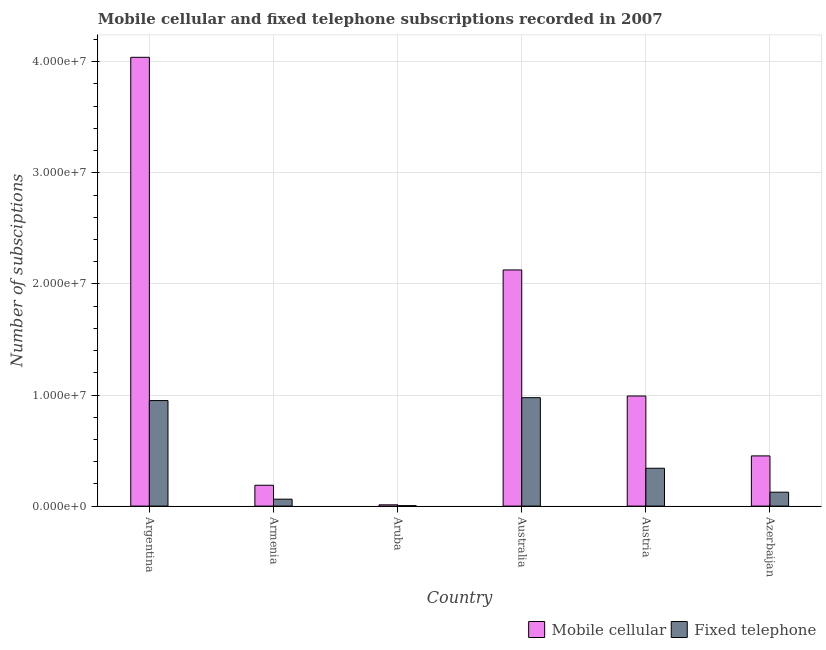How many groups of bars are there?
Your response must be concise. 6. Are the number of bars per tick equal to the number of legend labels?
Your answer should be very brief. Yes. How many bars are there on the 4th tick from the left?
Offer a terse response. 2. How many bars are there on the 1st tick from the right?
Offer a very short reply. 2. What is the label of the 1st group of bars from the left?
Your response must be concise. Argentina. What is the number of mobile cellular subscriptions in Argentina?
Your answer should be compact. 4.04e+07. Across all countries, what is the maximum number of mobile cellular subscriptions?
Your response must be concise. 4.04e+07. Across all countries, what is the minimum number of fixed telephone subscriptions?
Provide a short and direct response. 3.86e+04. In which country was the number of mobile cellular subscriptions minimum?
Provide a succinct answer. Aruba. What is the total number of fixed telephone subscriptions in the graph?
Offer a terse response. 2.46e+07. What is the difference between the number of mobile cellular subscriptions in Armenia and that in Azerbaijan?
Offer a very short reply. -2.64e+06. What is the difference between the number of mobile cellular subscriptions in Azerbaijan and the number of fixed telephone subscriptions in Austria?
Your answer should be compact. 1.11e+06. What is the average number of mobile cellular subscriptions per country?
Give a very brief answer. 1.30e+07. What is the difference between the number of mobile cellular subscriptions and number of fixed telephone subscriptions in Australia?
Make the answer very short. 1.15e+07. In how many countries, is the number of mobile cellular subscriptions greater than 14000000 ?
Your answer should be compact. 2. What is the ratio of the number of fixed telephone subscriptions in Argentina to that in Azerbaijan?
Your answer should be very brief. 7.58. Is the number of fixed telephone subscriptions in Armenia less than that in Aruba?
Provide a short and direct response. No. What is the difference between the highest and the second highest number of mobile cellular subscriptions?
Your answer should be compact. 1.91e+07. What is the difference between the highest and the lowest number of fixed telephone subscriptions?
Provide a short and direct response. 9.72e+06. What does the 1st bar from the left in Aruba represents?
Offer a terse response. Mobile cellular. What does the 2nd bar from the right in Australia represents?
Your response must be concise. Mobile cellular. Are all the bars in the graph horizontal?
Your answer should be very brief. No. How many countries are there in the graph?
Provide a succinct answer. 6. Are the values on the major ticks of Y-axis written in scientific E-notation?
Provide a succinct answer. Yes. Does the graph contain any zero values?
Provide a short and direct response. No. How many legend labels are there?
Your answer should be compact. 2. What is the title of the graph?
Make the answer very short. Mobile cellular and fixed telephone subscriptions recorded in 2007. Does "Highest 10% of population" appear as one of the legend labels in the graph?
Provide a succinct answer. No. What is the label or title of the X-axis?
Your answer should be very brief. Country. What is the label or title of the Y-axis?
Offer a terse response. Number of subsciptions. What is the Number of subsciptions of Mobile cellular in Argentina?
Offer a very short reply. 4.04e+07. What is the Number of subsciptions of Fixed telephone in Argentina?
Ensure brevity in your answer.  9.50e+06. What is the Number of subsciptions in Mobile cellular in Armenia?
Offer a terse response. 1.88e+06. What is the Number of subsciptions of Fixed telephone in Armenia?
Provide a succinct answer. 6.25e+05. What is the Number of subsciptions of Mobile cellular in Aruba?
Provide a short and direct response. 1.14e+05. What is the Number of subsciptions of Fixed telephone in Aruba?
Offer a terse response. 3.86e+04. What is the Number of subsciptions in Mobile cellular in Australia?
Give a very brief answer. 2.13e+07. What is the Number of subsciptions of Fixed telephone in Australia?
Offer a terse response. 9.76e+06. What is the Number of subsciptions in Mobile cellular in Austria?
Keep it short and to the point. 9.91e+06. What is the Number of subsciptions in Fixed telephone in Austria?
Offer a very short reply. 3.41e+06. What is the Number of subsciptions in Mobile cellular in Azerbaijan?
Keep it short and to the point. 4.52e+06. What is the Number of subsciptions of Fixed telephone in Azerbaijan?
Offer a terse response. 1.25e+06. Across all countries, what is the maximum Number of subsciptions of Mobile cellular?
Offer a very short reply. 4.04e+07. Across all countries, what is the maximum Number of subsciptions in Fixed telephone?
Provide a short and direct response. 9.76e+06. Across all countries, what is the minimum Number of subsciptions in Mobile cellular?
Offer a very short reply. 1.14e+05. Across all countries, what is the minimum Number of subsciptions in Fixed telephone?
Give a very brief answer. 3.86e+04. What is the total Number of subsciptions of Mobile cellular in the graph?
Provide a short and direct response. 7.81e+07. What is the total Number of subsciptions of Fixed telephone in the graph?
Your answer should be compact. 2.46e+07. What is the difference between the Number of subsciptions in Mobile cellular in Argentina and that in Armenia?
Provide a succinct answer. 3.85e+07. What is the difference between the Number of subsciptions of Fixed telephone in Argentina and that in Armenia?
Give a very brief answer. 8.88e+06. What is the difference between the Number of subsciptions of Mobile cellular in Argentina and that in Aruba?
Ensure brevity in your answer.  4.03e+07. What is the difference between the Number of subsciptions of Fixed telephone in Argentina and that in Aruba?
Ensure brevity in your answer.  9.46e+06. What is the difference between the Number of subsciptions in Mobile cellular in Argentina and that in Australia?
Provide a short and direct response. 1.91e+07. What is the difference between the Number of subsciptions of Mobile cellular in Argentina and that in Austria?
Ensure brevity in your answer.  3.05e+07. What is the difference between the Number of subsciptions of Fixed telephone in Argentina and that in Austria?
Give a very brief answer. 6.09e+06. What is the difference between the Number of subsciptions of Mobile cellular in Argentina and that in Azerbaijan?
Your response must be concise. 3.59e+07. What is the difference between the Number of subsciptions in Fixed telephone in Argentina and that in Azerbaijan?
Your answer should be very brief. 8.25e+06. What is the difference between the Number of subsciptions in Mobile cellular in Armenia and that in Aruba?
Your response must be concise. 1.76e+06. What is the difference between the Number of subsciptions of Fixed telephone in Armenia and that in Aruba?
Give a very brief answer. 5.86e+05. What is the difference between the Number of subsciptions of Mobile cellular in Armenia and that in Australia?
Give a very brief answer. -1.94e+07. What is the difference between the Number of subsciptions in Fixed telephone in Armenia and that in Australia?
Offer a terse response. -9.14e+06. What is the difference between the Number of subsciptions of Mobile cellular in Armenia and that in Austria?
Offer a very short reply. -8.04e+06. What is the difference between the Number of subsciptions of Fixed telephone in Armenia and that in Austria?
Give a very brief answer. -2.78e+06. What is the difference between the Number of subsciptions of Mobile cellular in Armenia and that in Azerbaijan?
Offer a terse response. -2.64e+06. What is the difference between the Number of subsciptions of Fixed telephone in Armenia and that in Azerbaijan?
Your answer should be very brief. -6.29e+05. What is the difference between the Number of subsciptions in Mobile cellular in Aruba and that in Australia?
Your response must be concise. -2.11e+07. What is the difference between the Number of subsciptions in Fixed telephone in Aruba and that in Australia?
Your answer should be very brief. -9.72e+06. What is the difference between the Number of subsciptions in Mobile cellular in Aruba and that in Austria?
Provide a succinct answer. -9.80e+06. What is the difference between the Number of subsciptions in Fixed telephone in Aruba and that in Austria?
Give a very brief answer. -3.37e+06. What is the difference between the Number of subsciptions in Mobile cellular in Aruba and that in Azerbaijan?
Provide a short and direct response. -4.41e+06. What is the difference between the Number of subsciptions in Fixed telephone in Aruba and that in Azerbaijan?
Offer a very short reply. -1.21e+06. What is the difference between the Number of subsciptions in Mobile cellular in Australia and that in Austria?
Your response must be concise. 1.13e+07. What is the difference between the Number of subsciptions in Fixed telephone in Australia and that in Austria?
Offer a terse response. 6.35e+06. What is the difference between the Number of subsciptions in Mobile cellular in Australia and that in Azerbaijan?
Give a very brief answer. 1.67e+07. What is the difference between the Number of subsciptions in Fixed telephone in Australia and that in Azerbaijan?
Your answer should be compact. 8.51e+06. What is the difference between the Number of subsciptions in Mobile cellular in Austria and that in Azerbaijan?
Offer a terse response. 5.39e+06. What is the difference between the Number of subsciptions of Fixed telephone in Austria and that in Azerbaijan?
Give a very brief answer. 2.15e+06. What is the difference between the Number of subsciptions in Mobile cellular in Argentina and the Number of subsciptions in Fixed telephone in Armenia?
Ensure brevity in your answer.  3.98e+07. What is the difference between the Number of subsciptions in Mobile cellular in Argentina and the Number of subsciptions in Fixed telephone in Aruba?
Provide a succinct answer. 4.04e+07. What is the difference between the Number of subsciptions in Mobile cellular in Argentina and the Number of subsciptions in Fixed telephone in Australia?
Give a very brief answer. 3.06e+07. What is the difference between the Number of subsciptions in Mobile cellular in Argentina and the Number of subsciptions in Fixed telephone in Austria?
Make the answer very short. 3.70e+07. What is the difference between the Number of subsciptions of Mobile cellular in Argentina and the Number of subsciptions of Fixed telephone in Azerbaijan?
Provide a short and direct response. 3.91e+07. What is the difference between the Number of subsciptions in Mobile cellular in Armenia and the Number of subsciptions in Fixed telephone in Aruba?
Ensure brevity in your answer.  1.84e+06. What is the difference between the Number of subsciptions in Mobile cellular in Armenia and the Number of subsciptions in Fixed telephone in Australia?
Your answer should be compact. -7.88e+06. What is the difference between the Number of subsciptions of Mobile cellular in Armenia and the Number of subsciptions of Fixed telephone in Austria?
Keep it short and to the point. -1.53e+06. What is the difference between the Number of subsciptions in Mobile cellular in Armenia and the Number of subsciptions in Fixed telephone in Azerbaijan?
Provide a succinct answer. 6.23e+05. What is the difference between the Number of subsciptions in Mobile cellular in Aruba and the Number of subsciptions in Fixed telephone in Australia?
Keep it short and to the point. -9.65e+06. What is the difference between the Number of subsciptions of Mobile cellular in Aruba and the Number of subsciptions of Fixed telephone in Austria?
Provide a succinct answer. -3.29e+06. What is the difference between the Number of subsciptions in Mobile cellular in Aruba and the Number of subsciptions in Fixed telephone in Azerbaijan?
Your answer should be compact. -1.14e+06. What is the difference between the Number of subsciptions in Mobile cellular in Australia and the Number of subsciptions in Fixed telephone in Austria?
Ensure brevity in your answer.  1.79e+07. What is the difference between the Number of subsciptions in Mobile cellular in Australia and the Number of subsciptions in Fixed telephone in Azerbaijan?
Your answer should be compact. 2.00e+07. What is the difference between the Number of subsciptions in Mobile cellular in Austria and the Number of subsciptions in Fixed telephone in Azerbaijan?
Your answer should be very brief. 8.66e+06. What is the average Number of subsciptions in Mobile cellular per country?
Make the answer very short. 1.30e+07. What is the average Number of subsciptions in Fixed telephone per country?
Give a very brief answer. 4.10e+06. What is the difference between the Number of subsciptions of Mobile cellular and Number of subsciptions of Fixed telephone in Argentina?
Offer a terse response. 3.09e+07. What is the difference between the Number of subsciptions in Mobile cellular and Number of subsciptions in Fixed telephone in Armenia?
Provide a succinct answer. 1.25e+06. What is the difference between the Number of subsciptions of Mobile cellular and Number of subsciptions of Fixed telephone in Aruba?
Make the answer very short. 7.50e+04. What is the difference between the Number of subsciptions of Mobile cellular and Number of subsciptions of Fixed telephone in Australia?
Offer a very short reply. 1.15e+07. What is the difference between the Number of subsciptions of Mobile cellular and Number of subsciptions of Fixed telephone in Austria?
Offer a very short reply. 6.50e+06. What is the difference between the Number of subsciptions of Mobile cellular and Number of subsciptions of Fixed telephone in Azerbaijan?
Your answer should be very brief. 3.27e+06. What is the ratio of the Number of subsciptions of Mobile cellular in Argentina to that in Armenia?
Keep it short and to the point. 21.53. What is the ratio of the Number of subsciptions of Fixed telephone in Argentina to that in Armenia?
Provide a succinct answer. 15.21. What is the ratio of the Number of subsciptions in Mobile cellular in Argentina to that in Aruba?
Your answer should be compact. 355.69. What is the ratio of the Number of subsciptions in Fixed telephone in Argentina to that in Aruba?
Offer a very short reply. 246.06. What is the ratio of the Number of subsciptions in Mobile cellular in Argentina to that in Australia?
Provide a succinct answer. 1.9. What is the ratio of the Number of subsciptions of Fixed telephone in Argentina to that in Australia?
Give a very brief answer. 0.97. What is the ratio of the Number of subsciptions of Mobile cellular in Argentina to that in Austria?
Offer a very short reply. 4.08. What is the ratio of the Number of subsciptions in Fixed telephone in Argentina to that in Austria?
Give a very brief answer. 2.79. What is the ratio of the Number of subsciptions in Mobile cellular in Argentina to that in Azerbaijan?
Offer a terse response. 8.94. What is the ratio of the Number of subsciptions in Fixed telephone in Argentina to that in Azerbaijan?
Make the answer very short. 7.58. What is the ratio of the Number of subsciptions of Mobile cellular in Armenia to that in Aruba?
Keep it short and to the point. 16.52. What is the ratio of the Number of subsciptions of Fixed telephone in Armenia to that in Aruba?
Offer a terse response. 16.18. What is the ratio of the Number of subsciptions of Mobile cellular in Armenia to that in Australia?
Provide a succinct answer. 0.09. What is the ratio of the Number of subsciptions of Fixed telephone in Armenia to that in Australia?
Provide a succinct answer. 0.06. What is the ratio of the Number of subsciptions of Mobile cellular in Armenia to that in Austria?
Offer a terse response. 0.19. What is the ratio of the Number of subsciptions in Fixed telephone in Armenia to that in Austria?
Give a very brief answer. 0.18. What is the ratio of the Number of subsciptions in Mobile cellular in Armenia to that in Azerbaijan?
Provide a short and direct response. 0.42. What is the ratio of the Number of subsciptions in Fixed telephone in Armenia to that in Azerbaijan?
Your response must be concise. 0.5. What is the ratio of the Number of subsciptions in Mobile cellular in Aruba to that in Australia?
Provide a short and direct response. 0.01. What is the ratio of the Number of subsciptions of Fixed telephone in Aruba to that in Australia?
Your answer should be very brief. 0. What is the ratio of the Number of subsciptions in Mobile cellular in Aruba to that in Austria?
Your answer should be compact. 0.01. What is the ratio of the Number of subsciptions in Fixed telephone in Aruba to that in Austria?
Make the answer very short. 0.01. What is the ratio of the Number of subsciptions in Mobile cellular in Aruba to that in Azerbaijan?
Offer a terse response. 0.03. What is the ratio of the Number of subsciptions of Fixed telephone in Aruba to that in Azerbaijan?
Your answer should be compact. 0.03. What is the ratio of the Number of subsciptions in Mobile cellular in Australia to that in Austria?
Your response must be concise. 2.14. What is the ratio of the Number of subsciptions of Fixed telephone in Australia to that in Austria?
Your answer should be very brief. 2.86. What is the ratio of the Number of subsciptions in Mobile cellular in Australia to that in Azerbaijan?
Your answer should be very brief. 4.7. What is the ratio of the Number of subsciptions in Fixed telephone in Australia to that in Azerbaijan?
Offer a terse response. 7.79. What is the ratio of the Number of subsciptions in Mobile cellular in Austria to that in Azerbaijan?
Your answer should be very brief. 2.19. What is the ratio of the Number of subsciptions of Fixed telephone in Austria to that in Azerbaijan?
Provide a succinct answer. 2.72. What is the difference between the highest and the second highest Number of subsciptions in Mobile cellular?
Keep it short and to the point. 1.91e+07. What is the difference between the highest and the second highest Number of subsciptions in Fixed telephone?
Offer a very short reply. 2.60e+05. What is the difference between the highest and the lowest Number of subsciptions of Mobile cellular?
Keep it short and to the point. 4.03e+07. What is the difference between the highest and the lowest Number of subsciptions of Fixed telephone?
Make the answer very short. 9.72e+06. 